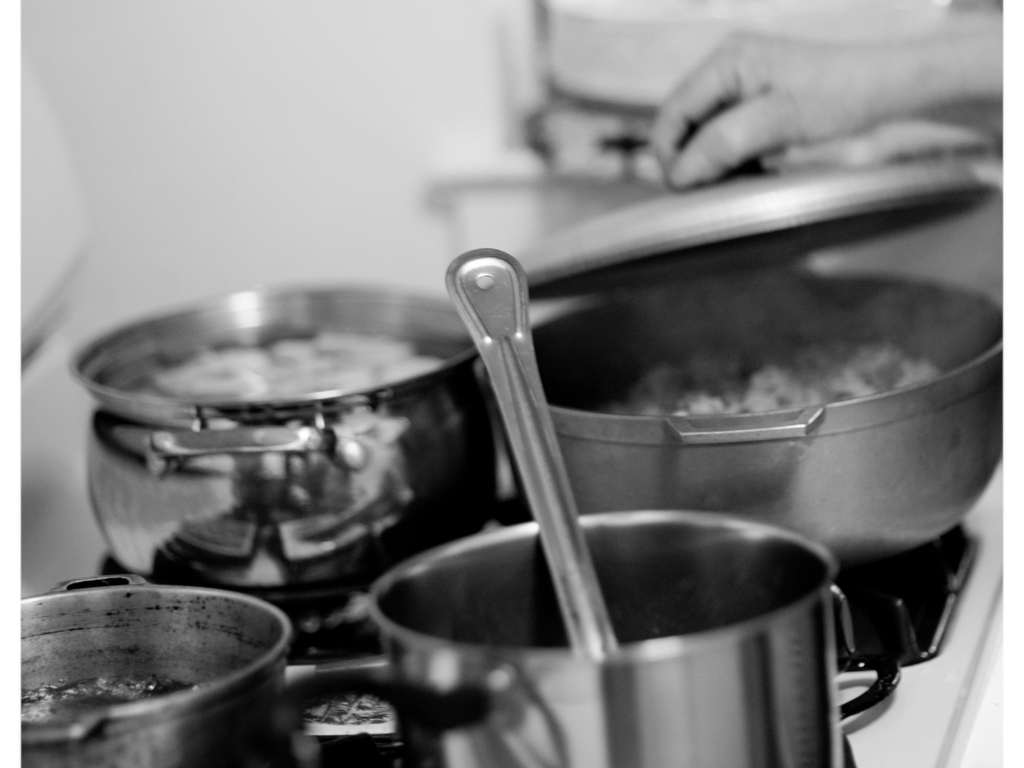What meal appears to be prepared in this image? The image shows pots and pans on a stove with steam rising, indicating that cooking is in progress. While the contents aren't clearly visible, the context suggests a meal involving boiling or simmering, possibly a soup or stew. 